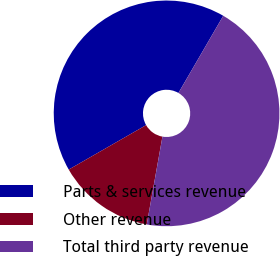<chart> <loc_0><loc_0><loc_500><loc_500><pie_chart><fcel>Parts & services revenue<fcel>Other revenue<fcel>Total third party revenue<nl><fcel>41.67%<fcel>13.89%<fcel>44.44%<nl></chart> 